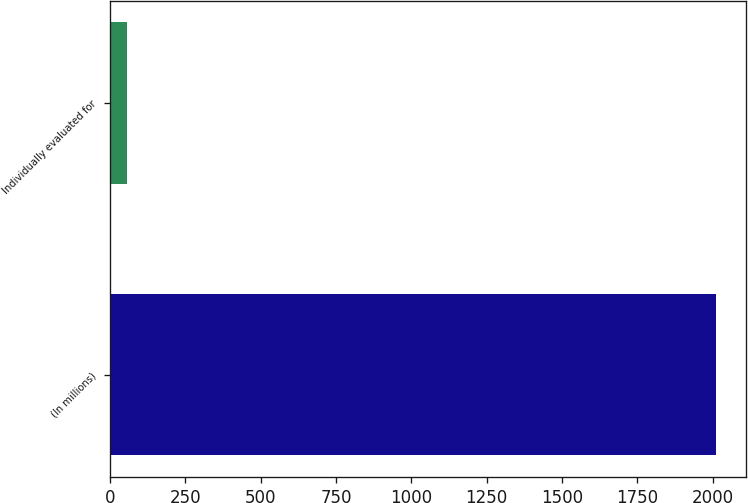Convert chart to OTSL. <chart><loc_0><loc_0><loc_500><loc_500><bar_chart><fcel>(In millions)<fcel>Individually evaluated for<nl><fcel>2011<fcel>56<nl></chart> 